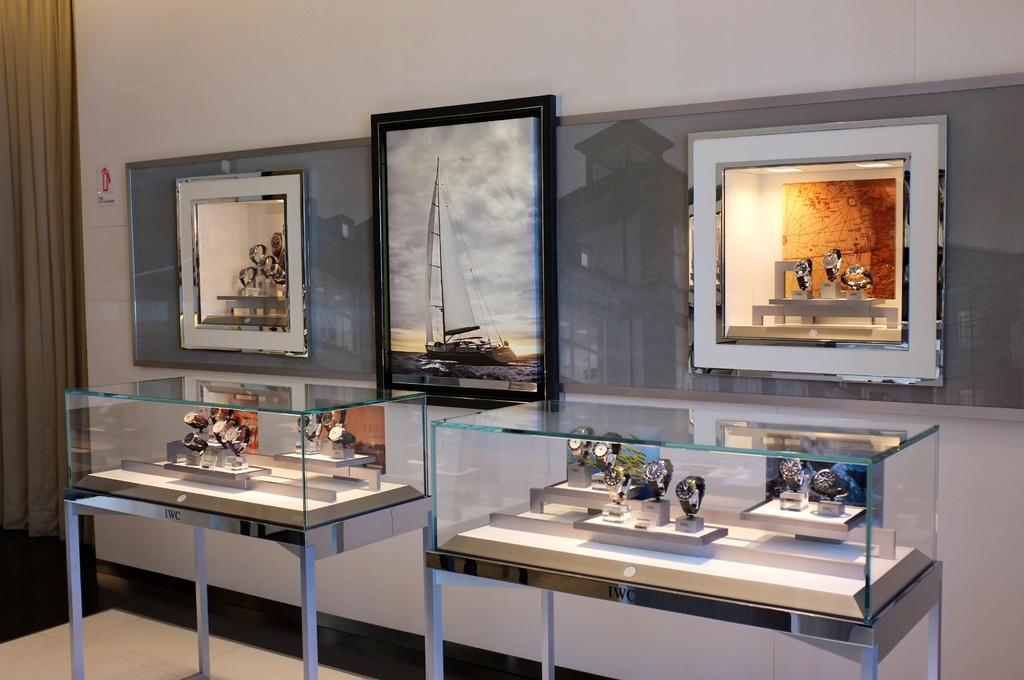In one or two sentences, can you explain what this image depicts? In this image, we can see display tables in front of the wall and contains some watches. There are photo frames in the middle of the image. There is a curtain on the left side of the image. 